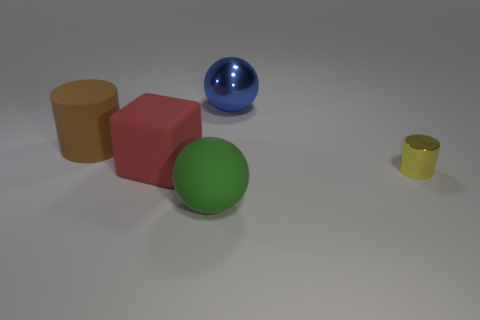Are there any other things that have the same size as the metallic cylinder?
Keep it short and to the point. No. There is a metal thing that is behind the tiny thing; what color is it?
Your answer should be compact. Blue. What is the shape of the tiny thing?
Ensure brevity in your answer.  Cylinder. Are there any brown rubber objects to the right of the sphere in front of the big thing to the left of the red rubber block?
Ensure brevity in your answer.  No. The metal object that is behind the cylinder that is on the right side of the matte cylinder behind the yellow cylinder is what color?
Your answer should be compact. Blue. What material is the large brown thing that is the same shape as the tiny yellow metallic thing?
Ensure brevity in your answer.  Rubber. How big is the shiny thing that is in front of the ball that is behind the big brown rubber object?
Keep it short and to the point. Small. There is a cylinder left of the green ball; what is its material?
Provide a short and direct response. Rubber. There is a cylinder that is made of the same material as the big blue sphere; what size is it?
Provide a short and direct response. Small. How many large brown objects have the same shape as the tiny thing?
Provide a succinct answer. 1. 